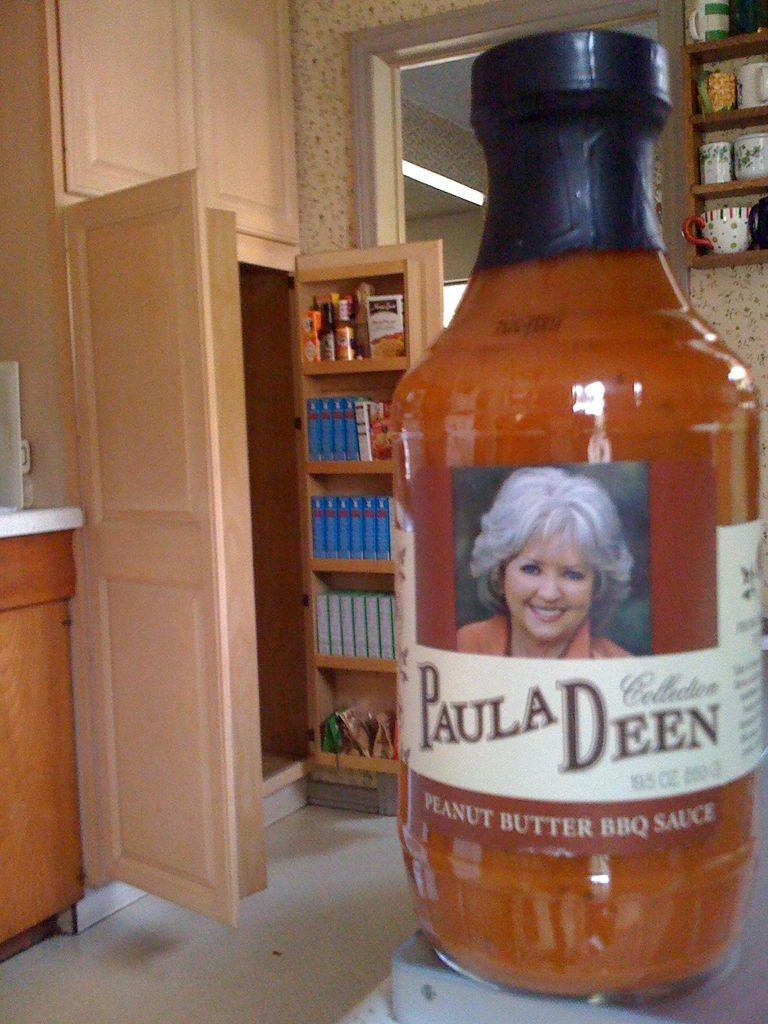Who is on the bottle?
Your answer should be compact. Paula deen. What is the sauce?
Keep it short and to the point. Peanut butter bbq sauce. 